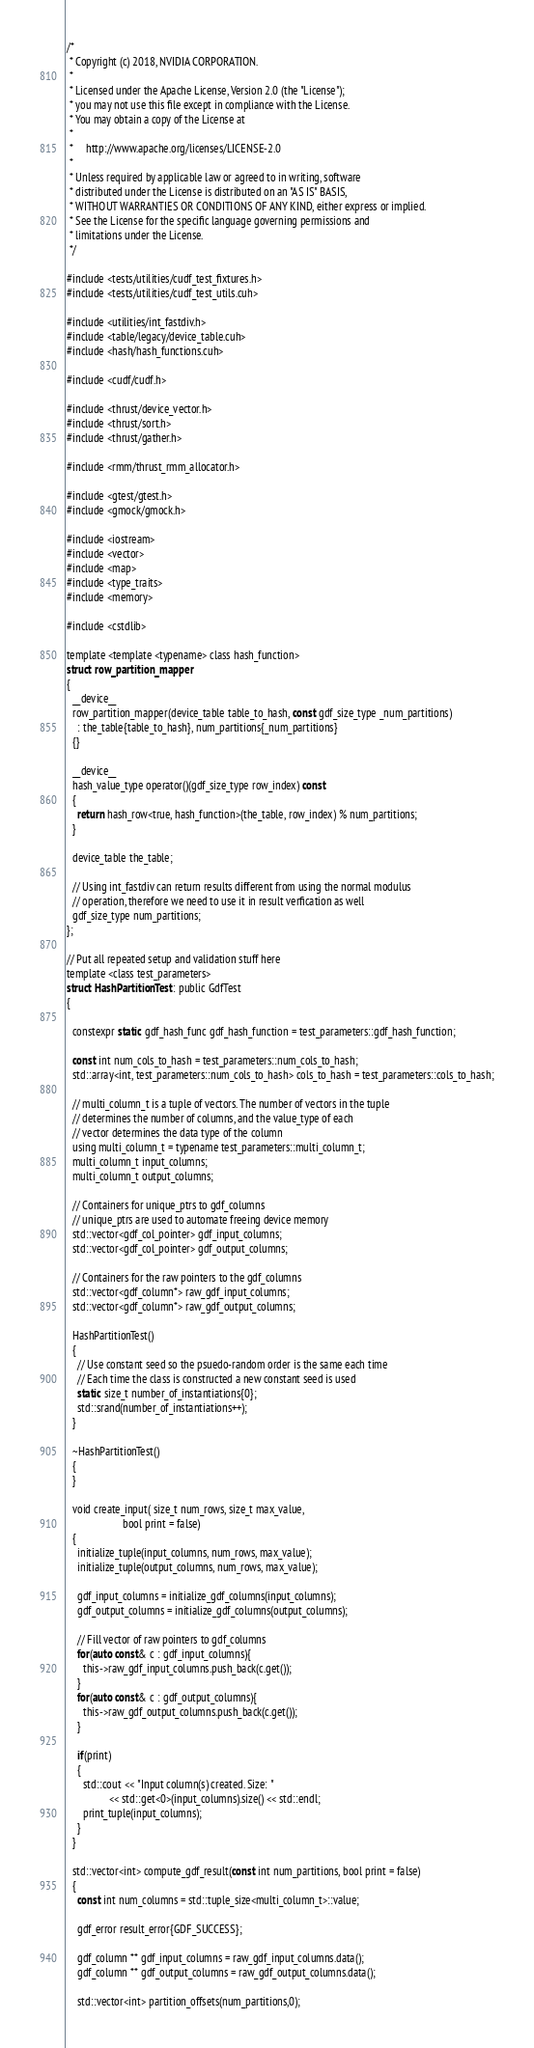<code> <loc_0><loc_0><loc_500><loc_500><_Cuda_>/*
 * Copyright (c) 2018, NVIDIA CORPORATION.
 *
 * Licensed under the Apache License, Version 2.0 (the "License");
 * you may not use this file except in compliance with the License.
 * You may obtain a copy of the License at
 *
 *     http://www.apache.org/licenses/LICENSE-2.0
 *
 * Unless required by applicable law or agreed to in writing, software
 * distributed under the License is distributed on an "AS IS" BASIS,
 * WITHOUT WARRANTIES OR CONDITIONS OF ANY KIND, either express or implied.
 * See the License for the specific language governing permissions and
 * limitations under the License.
 */

#include <tests/utilities/cudf_test_fixtures.h>
#include <tests/utilities/cudf_test_utils.cuh>

#include <utilities/int_fastdiv.h>
#include <table/legacy/device_table.cuh>
#include <hash/hash_functions.cuh>

#include <cudf/cudf.h>

#include <thrust/device_vector.h>
#include <thrust/sort.h>
#include <thrust/gather.h>

#include <rmm/thrust_rmm_allocator.h>

#include <gtest/gtest.h>
#include <gmock/gmock.h>

#include <iostream>
#include <vector>
#include <map>
#include <type_traits>
#include <memory>

#include <cstdlib>

template <template <typename> class hash_function>
struct row_partition_mapper
{
  __device__
  row_partition_mapper(device_table table_to_hash, const gdf_size_type _num_partitions)
    : the_table{table_to_hash}, num_partitions{_num_partitions}
  {}

  __device__
  hash_value_type operator()(gdf_size_type row_index) const
  {
    return hash_row<true, hash_function>(the_table, row_index) % num_partitions;
  }

  device_table the_table;

  // Using int_fastdiv can return results different from using the normal modulus
  // operation, therefore we need to use it in result verfication as well
  gdf_size_type num_partitions;
};

// Put all repeated setup and validation stuff here
template <class test_parameters>
struct HashPartitionTest : public GdfTest
{

  constexpr static gdf_hash_func gdf_hash_function = test_parameters::gdf_hash_function;

  const int num_cols_to_hash = test_parameters::num_cols_to_hash;
  std::array<int, test_parameters::num_cols_to_hash> cols_to_hash = test_parameters::cols_to_hash;

  // multi_column_t is a tuple of vectors. The number of vectors in the tuple
  // determines the number of columns, and the value_type of each
  // vector determines the data type of the column
  using multi_column_t = typename test_parameters::multi_column_t;
  multi_column_t input_columns;
  multi_column_t output_columns;

  // Containers for unique_ptrs to gdf_columns 
  // unique_ptrs are used to automate freeing device memory
  std::vector<gdf_col_pointer> gdf_input_columns;
  std::vector<gdf_col_pointer> gdf_output_columns;

  // Containers for the raw pointers to the gdf_columns
  std::vector<gdf_column*> raw_gdf_input_columns;
  std::vector<gdf_column*> raw_gdf_output_columns;

  HashPartitionTest()
  {
    // Use constant seed so the psuedo-random order is the same each time
    // Each time the class is constructed a new constant seed is used
    static size_t number_of_instantiations{0};
    std::srand(number_of_instantiations++);
  }

  ~HashPartitionTest()
  {
  }

  void create_input( size_t num_rows, size_t max_value,
                     bool print = false)
  {
    initialize_tuple(input_columns, num_rows, max_value);
    initialize_tuple(output_columns, num_rows, max_value);

    gdf_input_columns = initialize_gdf_columns(input_columns);
    gdf_output_columns = initialize_gdf_columns(output_columns);

    // Fill vector of raw pointers to gdf_columns
    for(auto const& c : gdf_input_columns){
      this->raw_gdf_input_columns.push_back(c.get());
    }
    for(auto const& c : gdf_output_columns){
      this->raw_gdf_output_columns.push_back(c.get());
    }

    if(print)
    {
      std::cout << "Input column(s) created. Size: " 
                << std::get<0>(input_columns).size() << std::endl;
      print_tuple(input_columns);
    }
  }

  std::vector<int> compute_gdf_result(const int num_partitions, bool print = false)
  {
    const int num_columns = std::tuple_size<multi_column_t>::value;

    gdf_error result_error{GDF_SUCCESS};

    gdf_column ** gdf_input_columns = raw_gdf_input_columns.data();
    gdf_column ** gdf_output_columns = raw_gdf_output_columns.data();

    std::vector<int> partition_offsets(num_partitions,0);
</code> 